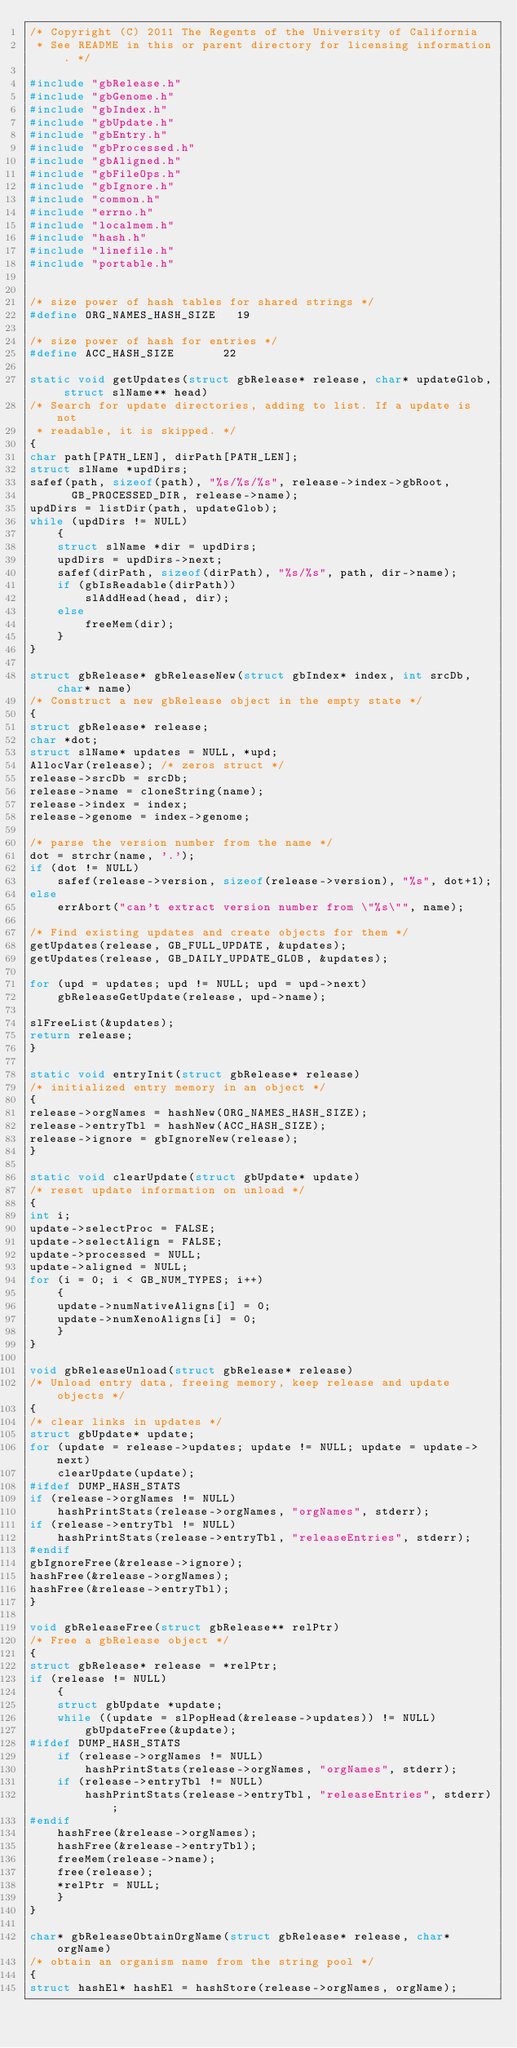Convert code to text. <code><loc_0><loc_0><loc_500><loc_500><_C_>/* Copyright (C) 2011 The Regents of the University of California 
 * See README in this or parent directory for licensing information. */

#include "gbRelease.h"
#include "gbGenome.h"
#include "gbIndex.h"
#include "gbUpdate.h"
#include "gbEntry.h"
#include "gbProcessed.h"
#include "gbAligned.h"
#include "gbFileOps.h"
#include "gbIgnore.h"
#include "common.h"
#include "errno.h"
#include "localmem.h"
#include "hash.h"
#include "linefile.h"
#include "portable.h"


/* size power of hash tables for shared strings */
#define ORG_NAMES_HASH_SIZE   19

/* size power of hash for entries */
#define ACC_HASH_SIZE       22

static void getUpdates(struct gbRelease* release, char* updateGlob, struct slName** head)
/* Search for update directories, adding to list. If a update is not
 * readable, it is skipped. */
{
char path[PATH_LEN], dirPath[PATH_LEN];
struct slName *updDirs;
safef(path, sizeof(path), "%s/%s/%s", release->index->gbRoot,
      GB_PROCESSED_DIR, release->name);
updDirs = listDir(path, updateGlob);
while (updDirs != NULL)
    {
    struct slName *dir = updDirs;
    updDirs = updDirs->next;
    safef(dirPath, sizeof(dirPath), "%s/%s", path, dir->name);
    if (gbIsReadable(dirPath))
        slAddHead(head, dir);
    else
        freeMem(dir);
    }
}

struct gbRelease* gbReleaseNew(struct gbIndex* index, int srcDb, char* name)
/* Construct a new gbRelease object in the empty state */
{
struct gbRelease* release;
char *dot;
struct slName* updates = NULL, *upd;
AllocVar(release); /* zeros struct */
release->srcDb = srcDb;
release->name = cloneString(name);
release->index = index;
release->genome = index->genome;

/* parse the version number from the name */
dot = strchr(name, '.');
if (dot != NULL)
    safef(release->version, sizeof(release->version), "%s", dot+1);
else
    errAbort("can't extract version number from \"%s\"", name);

/* Find existing updates and create objects for them */
getUpdates(release, GB_FULL_UPDATE, &updates);
getUpdates(release, GB_DAILY_UPDATE_GLOB, &updates);

for (upd = updates; upd != NULL; upd = upd->next)
    gbReleaseGetUpdate(release, upd->name);

slFreeList(&updates);
return release;
}

static void entryInit(struct gbRelease* release)
/* initialized entry memory in an object */
{
release->orgNames = hashNew(ORG_NAMES_HASH_SIZE);
release->entryTbl = hashNew(ACC_HASH_SIZE);
release->ignore = gbIgnoreNew(release);
}

static void clearUpdate(struct gbUpdate* update)
/* reset update information on unload */
{
int i;
update->selectProc = FALSE;
update->selectAlign = FALSE;
update->processed = NULL;
update->aligned = NULL;
for (i = 0; i < GB_NUM_TYPES; i++)
    {
    update->numNativeAligns[i] = 0;
    update->numXenoAligns[i] = 0;
    }
}

void gbReleaseUnload(struct gbRelease* release)
/* Unload entry data, freeing memory, keep release and update objects */
{
/* clear links in updates */
struct gbUpdate* update;
for (update = release->updates; update != NULL; update = update->next)
    clearUpdate(update);
#ifdef DUMP_HASH_STATS
if (release->orgNames != NULL)
    hashPrintStats(release->orgNames, "orgNames", stderr);
if (release->entryTbl != NULL)
    hashPrintStats(release->entryTbl, "releaseEntries", stderr);
#endif
gbIgnoreFree(&release->ignore);
hashFree(&release->orgNames);
hashFree(&release->entryTbl);
}

void gbReleaseFree(struct gbRelease** relPtr)
/* Free a gbRelease object */
{
struct gbRelease* release = *relPtr;
if (release != NULL)
    {
    struct gbUpdate *update;
    while ((update = slPopHead(&release->updates)) != NULL)
        gbUpdateFree(&update);
#ifdef DUMP_HASH_STATS
    if (release->orgNames != NULL)
        hashPrintStats(release->orgNames, "orgNames", stderr);
    if (release->entryTbl != NULL)
        hashPrintStats(release->entryTbl, "releaseEntries", stderr);
#endif
    hashFree(&release->orgNames);
    hashFree(&release->entryTbl);
    freeMem(release->name);
    free(release);
    *relPtr = NULL;
    }
}

char* gbReleaseObtainOrgName(struct gbRelease* release, char* orgName)
/* obtain an organism name from the string pool */
{
struct hashEl* hashEl = hashStore(release->orgNames, orgName);</code> 